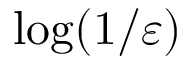<formula> <loc_0><loc_0><loc_500><loc_500>\log ( 1 / \varepsilon )</formula> 